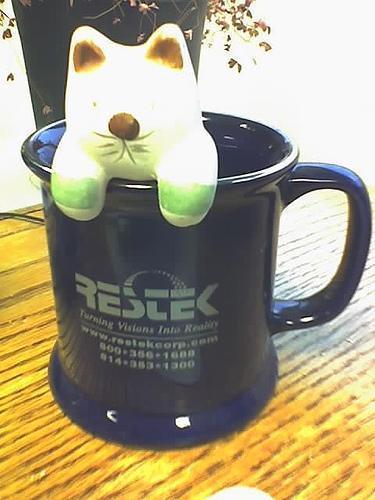How many coffee mugs?
Give a very brief answer. 1. 